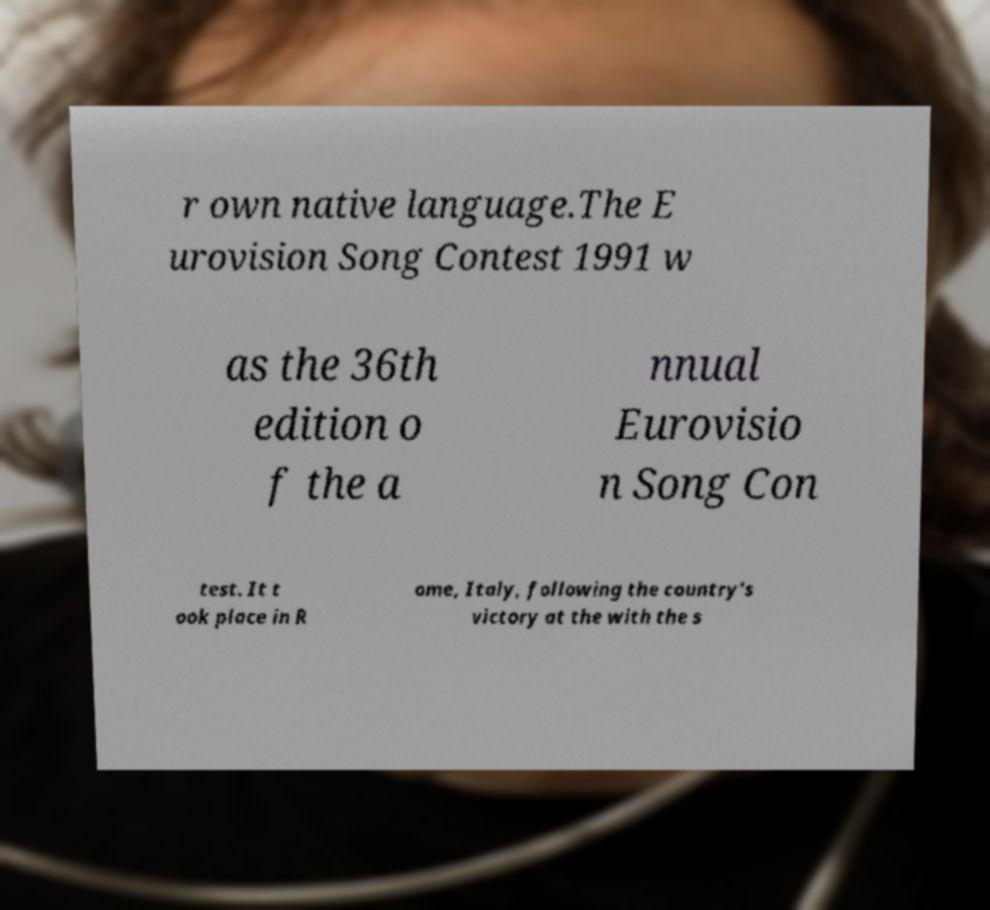Please identify and transcribe the text found in this image. r own native language.The E urovision Song Contest 1991 w as the 36th edition o f the a nnual Eurovisio n Song Con test. It t ook place in R ome, Italy, following the country's victory at the with the s 